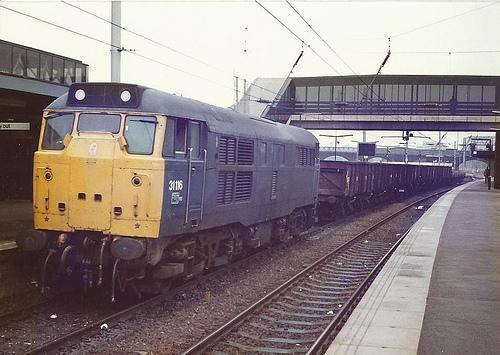How many trains are in the image?
Give a very brief answer. 1. How many windows are on the front of the train?
Give a very brief answer. 3. 